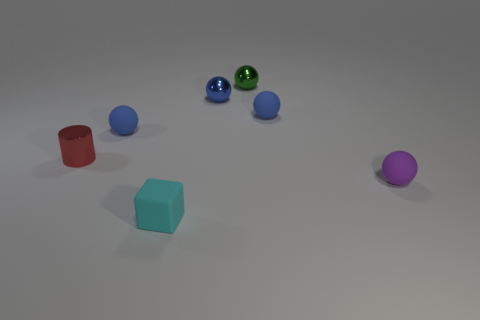Subtract all blue balls. How many were subtracted if there are1blue balls left? 2 Subtract all tiny green spheres. How many spheres are left? 4 Add 2 small red cylinders. How many objects exist? 9 Subtract all blue spheres. How many spheres are left? 2 Subtract all brown blocks. How many blue spheres are left? 3 Subtract 1 spheres. How many spheres are left? 4 Subtract all cubes. How many objects are left? 6 Subtract all cyan balls. Subtract all blue cylinders. How many balls are left? 5 Subtract all small red cylinders. Subtract all tiny green shiny spheres. How many objects are left? 5 Add 2 small red shiny objects. How many small red shiny objects are left? 3 